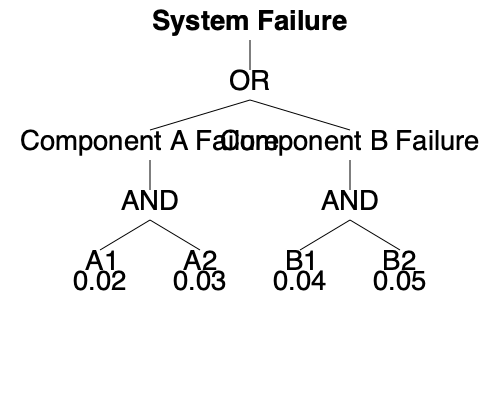Given the fault tree analysis diagram for a system with two components (A and B), each with two sub-components (A1, A2 and B1, B2), calculate the probability of system failure. Assume independence between events and use the probabilities provided in the diagram for each sub-component. To calculate the probability of system failure, we'll follow these steps:

1. Calculate the probability of Component A failure:
   $P(A) = P(A1) \times P(A2)$ (AND gate)
   $P(A) = 0.02 \times 0.03 = 0.0006$

2. Calculate the probability of Component B failure:
   $P(B) = P(B1) \times P(B2)$ (AND gate)
   $P(B) = 0.04 \times 0.05 = 0.002$

3. Calculate the probability of system failure:
   $P(System Failure) = 1 - (1 - P(A)) \times (1 - P(B))$ (OR gate)
   $P(System Failure) = 1 - (1 - 0.0006) \times (1 - 0.002)$
   $P(System Failure) = 1 - 0.9994 \times 0.998$
   $P(System Failure) = 1 - 0.9974$
   $P(System Failure) = 0.0026$

Therefore, the probability of system failure is 0.0026 or 0.26%.
Answer: 0.0026 